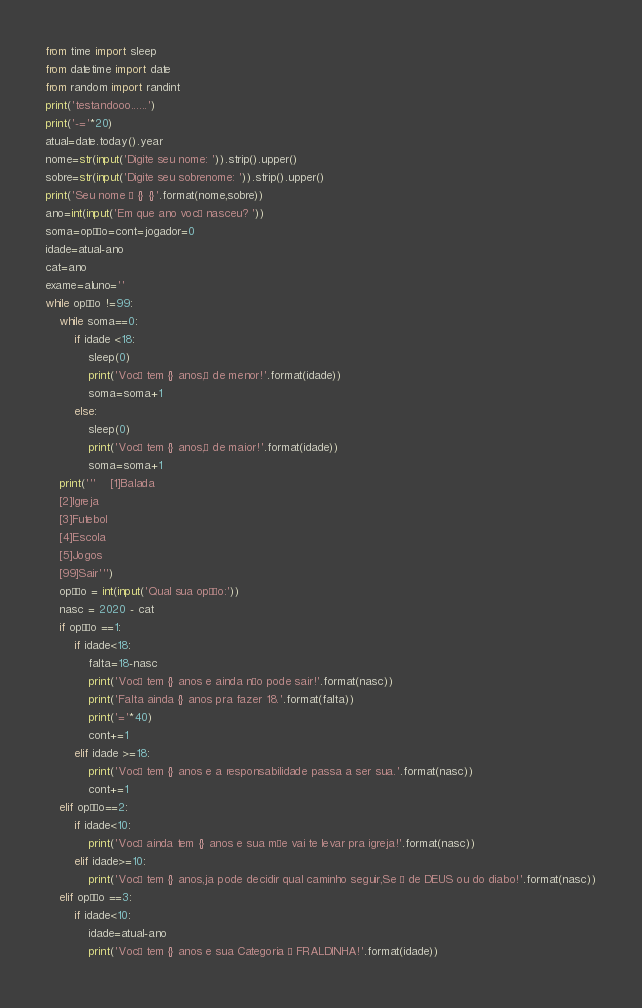<code> <loc_0><loc_0><loc_500><loc_500><_Python_>from time import sleep
from datetime import date
from random import randint
print('testandooo......')
print('-='*20)
atual=date.today().year
nome=str(input('Digite seu nome: ')).strip().upper()
sobre=str(input('Digite seu sobrenome: ')).strip().upper()
print('Seu nome é {} {}'.format(nome,sobre))
ano=int(input('Em que ano você nasceu? '))
soma=opção=cont=jogador=0
idade=atual-ano
cat=ano
exame=aluno=''
while opção !=99:
    while soma==0:
        if idade <18:
            sleep(0)
            print('Você tem {} anos,é de menor!'.format(idade))
            soma=soma+1
        else:
            sleep(0)
            print('Você tem {} anos,é de maior!'.format(idade))
            soma=soma+1
    print('''    [1]Balada
    [2]Igreja
    [3]Futebol
    [4]Escola
    [5]Jogos
    [99]Sair''')
    opção = int(input('Qual sua opção:'))
    nasc = 2020 - cat
    if opção ==1:
        if idade<18:
            falta=18-nasc
            print('Você tem {} anos e ainda não pode sair!'.format(nasc))
            print('Falta ainda {} anos pra fazer 18.'.format(falta))
            print('='*40)
            cont+=1
        elif idade >=18:
            print('Você tem {} anos e a responsabilidade passa a ser sua.'.format(nasc))
            cont+=1
    elif opção==2:
        if idade<10:
            print('Você ainda tem {} anos e sua mãe vai te levar pra igreja!'.format(nasc))
        elif idade>=10:
            print('Você tem {} anos,ja pode decidir qual caminho seguir,Se é de DEUS ou do diabo!'.format(nasc))
    elif opção ==3:
        if idade<10:
            idade=atual-ano
            print('Você tem {} anos e sua Categoria é FRALDINHA!'.format(idade))</code> 